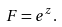<formula> <loc_0><loc_0><loc_500><loc_500>F = e ^ { z } .</formula> 